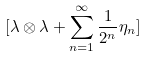Convert formula to latex. <formula><loc_0><loc_0><loc_500><loc_500>[ \lambda \otimes \lambda + \sum _ { n = 1 } ^ { \infty } \frac { 1 } { 2 ^ { n } } \eta _ { n } ]</formula> 